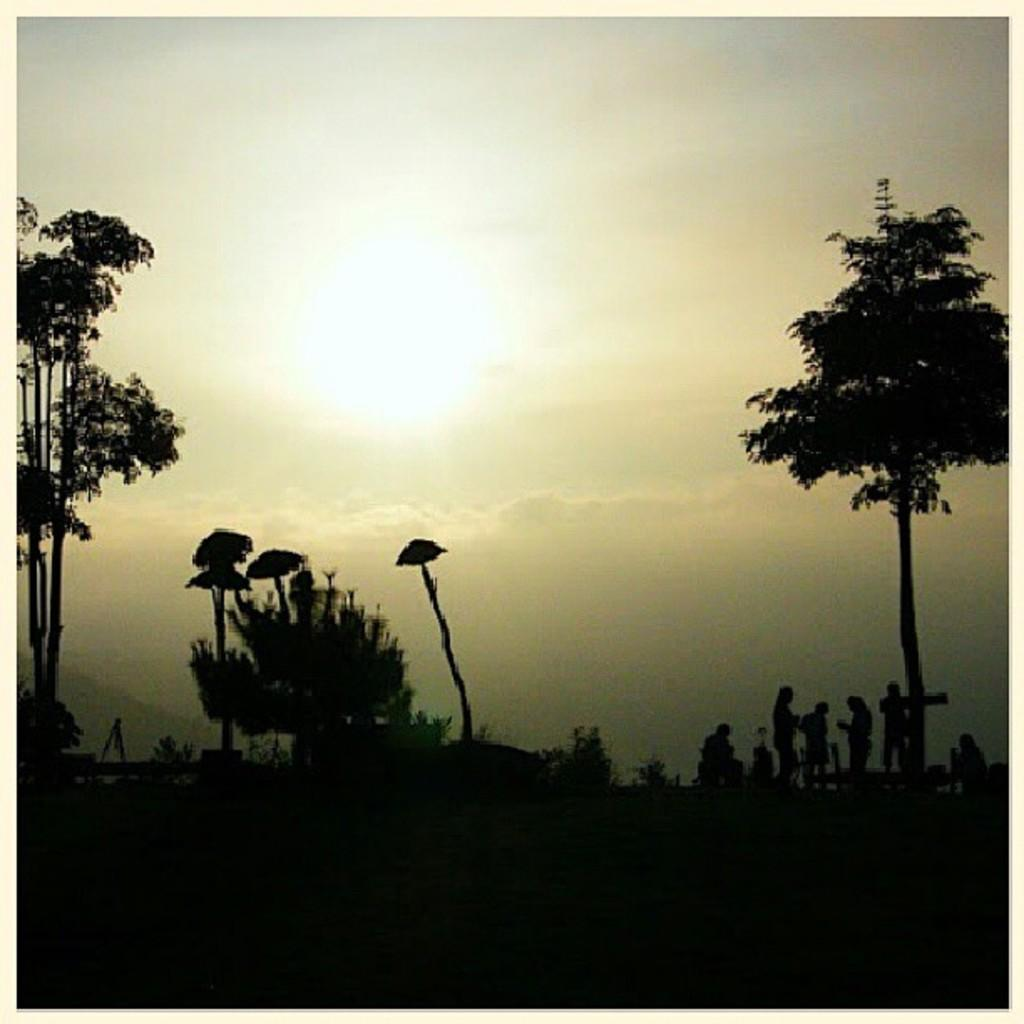What type of vegetation can be seen in the image? There are trees in the image. Where are the people located in the image? The people are on the right side of the image. What can be seen in the background of the image? There is sky visible in the background of the image. Can you see a crown on the trees in the image? There is no crown present on the trees in the image. How many ears can be counted on the people in the image? The image does not show the people's ears, so it is not possible to count them. 